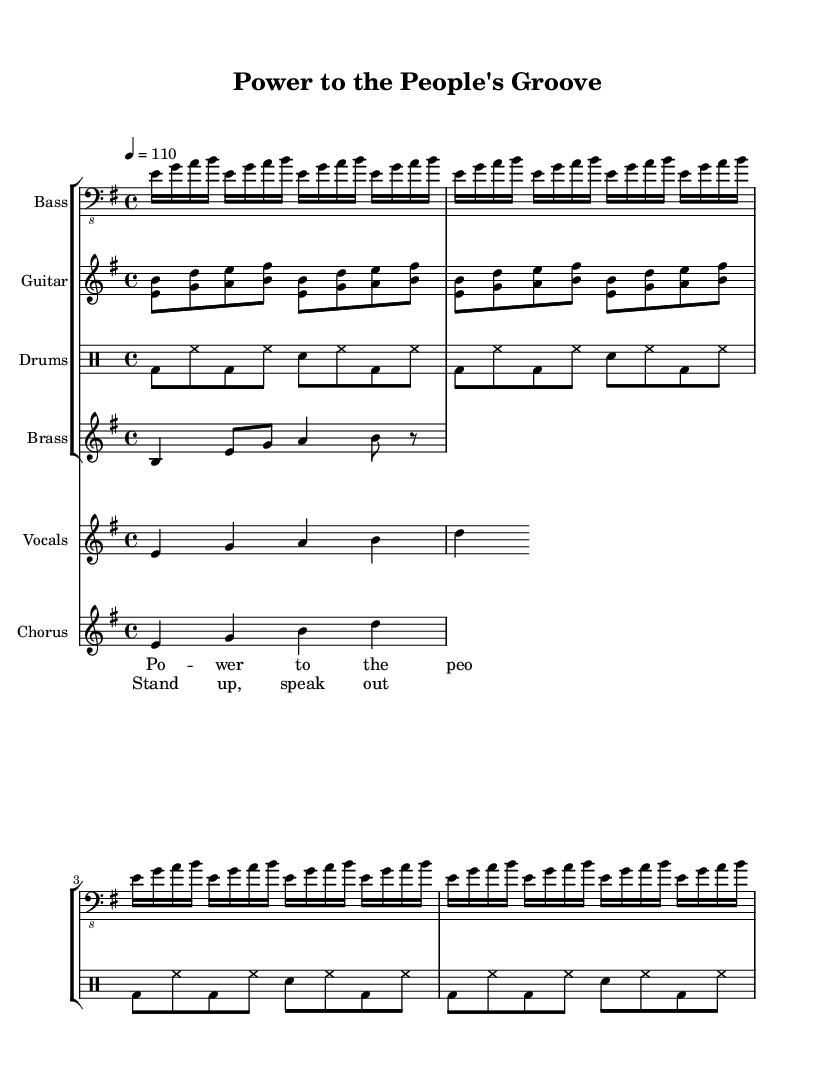What is the key signature of this piece? The key signature shown in the music indicates E minor, which has one sharp (F sharp).
Answer: E minor What is the time signature of this music? The time signature in the sheet music is 4/4, which means there are four beats in each measure.
Answer: 4/4 What is the tempo marking for this piece? The tempo marking is indicated as 4 equals 110, meaning the quarter note should be played at 110 beats per minute.
Answer: 110 How many measures are repeated in the bass line? The bass line has the instruction to repeat unfold 4 times, indicating that the same four measures are played multiple times.
Answer: 4 Which instrument plays the main vocal melody? The main vocal melody is performed by the vocal staff indicated in the score, specifically labeled for "Vocals."
Answer: Vocals What lyrics are associated with the vocal melody? The lyrics provided in the vocal section match the melody, specifically the line "Power to the people."
Answer: Power to the people What style of music does this sheet represent? Given the title and the elements within the score (such as the groove, brass section, and lyrical theme), this piece fits the genre of funk, specifically 70s protest funk.
Answer: Funk 